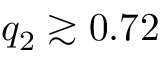Convert formula to latex. <formula><loc_0><loc_0><loc_500><loc_500>q _ { 2 } \gtrsim 0 . 7 2</formula> 